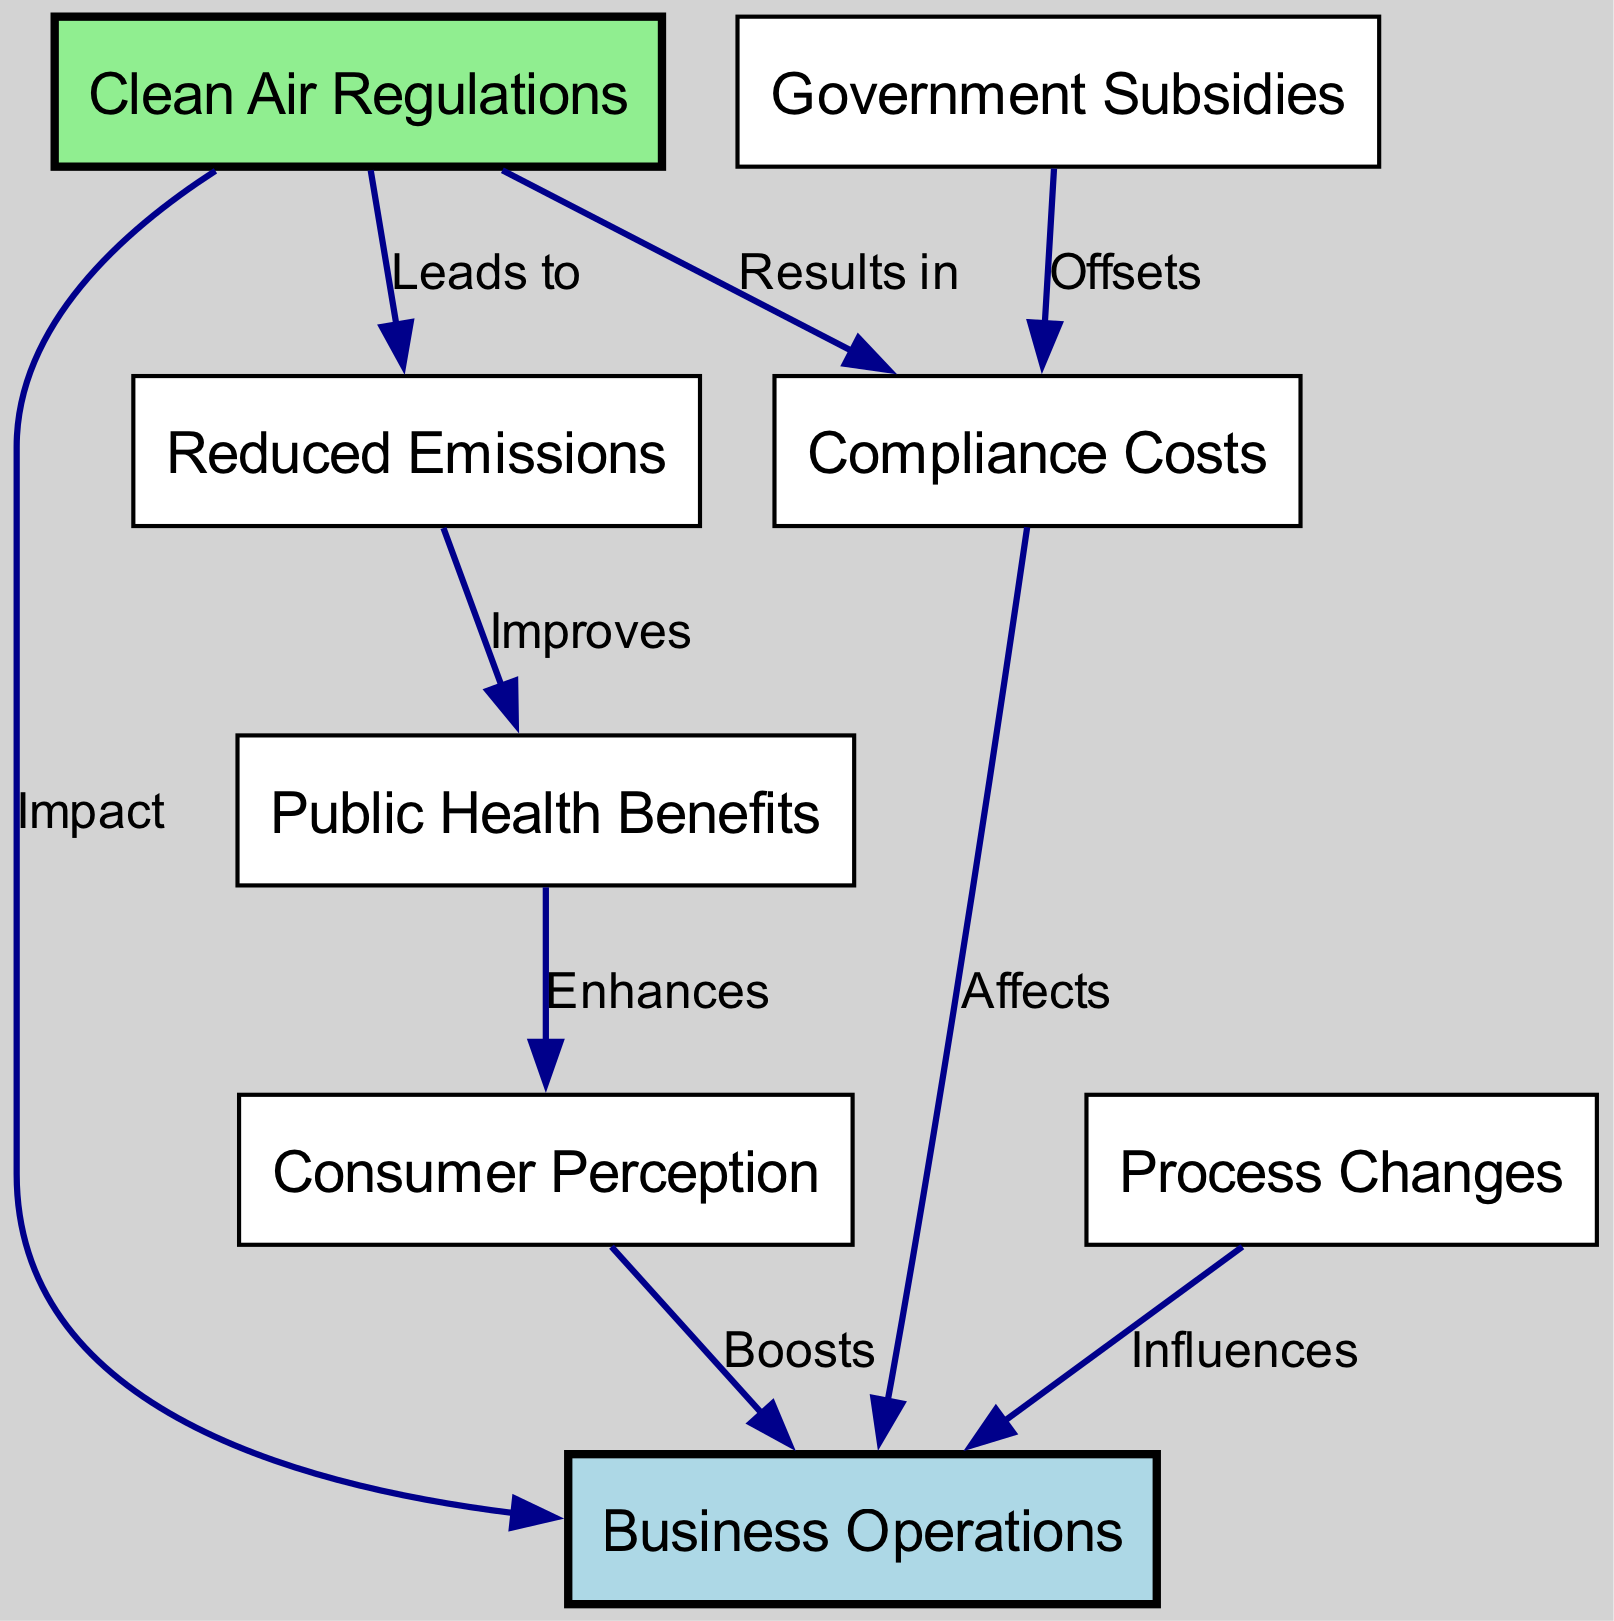What is the main focus of the diagram? The diagram focuses on the "Impact" of "Clean Air Regulations" on various aspects of "Business Operations."
Answer: Impact of clean air regulations How many nodes are present in the diagram? The diagram contains a total of eight nodes, which include various elements related to business operations and clean air regulations.
Answer: Eight What relationship does "Clean Air Regulations" have with "Reduced Emissions"? "Clean Air Regulations" leads to "Reduced Emissions," indicating a positive outcome as a result of the regulations.
Answer: Leads to What does "Compliance Costs" affect in the diagram? "Compliance Costs" affects "Business Operations," showing that the costs incurred due to regulations have an impact on how businesses operate.
Answer: Business Operations Which node enhances "Consumer Perception"? The "Health Benefits" node enhances "Consumer Perception," suggesting that improved public health may positively influence how consumers view a business.
Answer: Health benefits How do "Government Subsidies" relate to "Compliance Costs"? "Government Subsidies" offsets "Compliance Costs," meaning that financial support from the government can help businesses manage regulatory costs.
Answer: Offsets What does "Reduced Emissions" improve according to the diagram? "Reduced Emissions" improves "Public Health Benefits," indicating that less pollution contributes to better health outcomes for the public.
Answer: Public health benefits Which node is directly influenced by "Process Changes"? "Process Changes" influences "Business Operations," signifying that alterations in processes may affect how a business functions.
Answer: Business Operations How does "Consumer Perception" impact "Business Operations"? "Consumer Perception" boosts "Business Operations," meaning that a favorable view from consumers can lead to enhanced business performance.
Answer: Boosts 